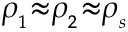<formula> <loc_0><loc_0><loc_500><loc_500>\rho _ { _ { 1 } } { \approx } \rho _ { _ { 2 } } { \approx } \rho _ { _ { s } }</formula> 